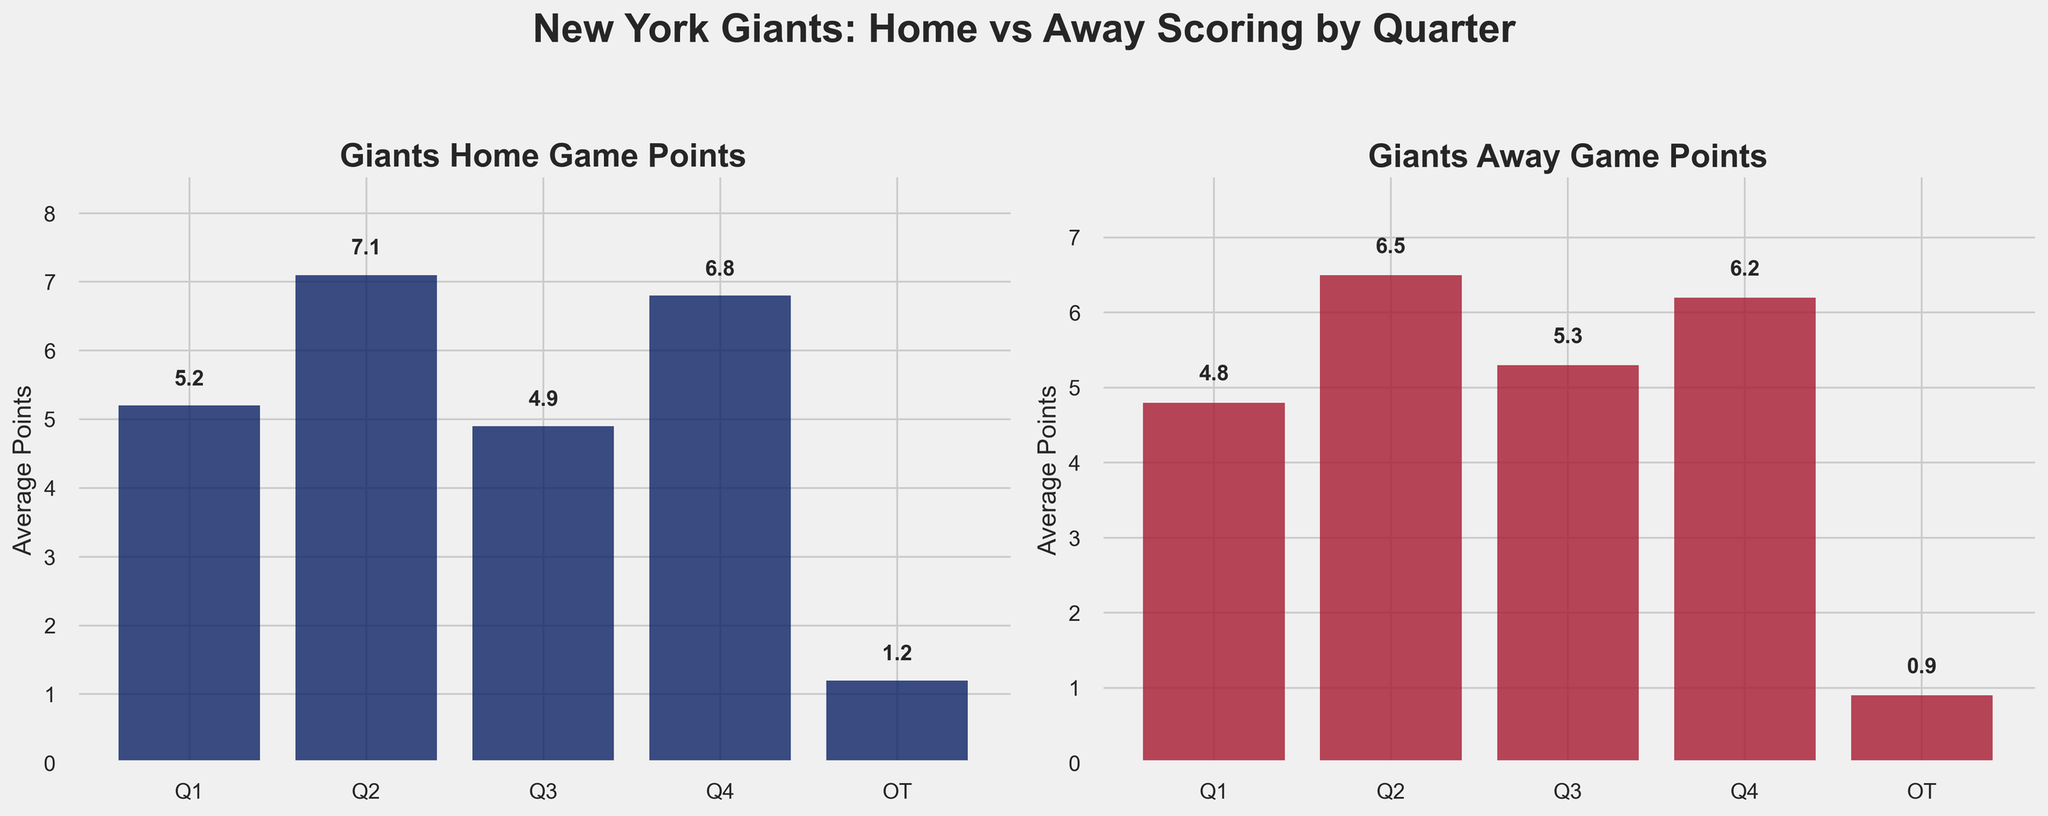Which quarter do the Giants score the most points in home games? By visually inspecting the height of the bars in the home game plot, we see that the highest bar corresponds to Q2.
Answer: Q2 How do the Giants' scores in the fourth quarter compare between home and away games? Comparing the height of the bars for Q4 in both plots, the home game bar is taller than the away game bar.
Answer: Higher in home games What's the difference between the Giants' average points scored in the first quarter of home games and away games? The first quarter home game bar shows 5.2 points and the away game bar shows 4.8 points. The difference is 5.2 - 4.8 = 0.4 points.
Answer: 0.4 points Which quarter shows the greatest average points in away games? By visually inspecting the height of the bars in the away game plot, the highest bar corresponds to Q2.
Answer: Q2 By how much do the Giants' scores improve in overtime at home compared to away games? The overtime home game bar shows 1.2 points, and the away game bar shows 0.9 points. The improvement is 1.2 - 0.9 = 0.3 points.
Answer: 0.3 points 